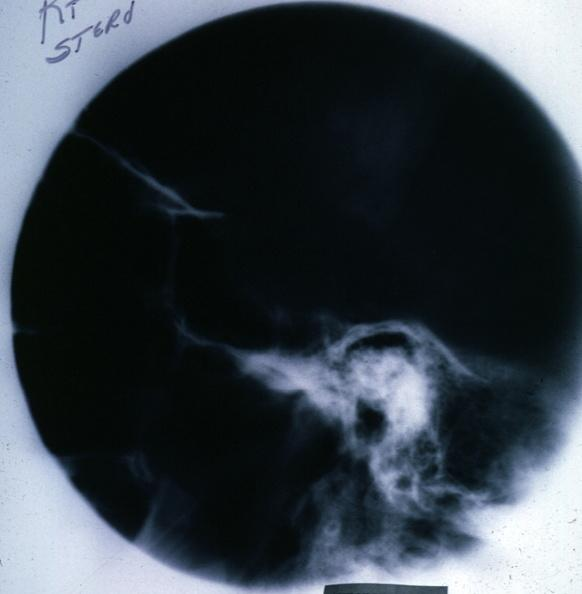s sella present?
Answer the question using a single word or phrase. No 